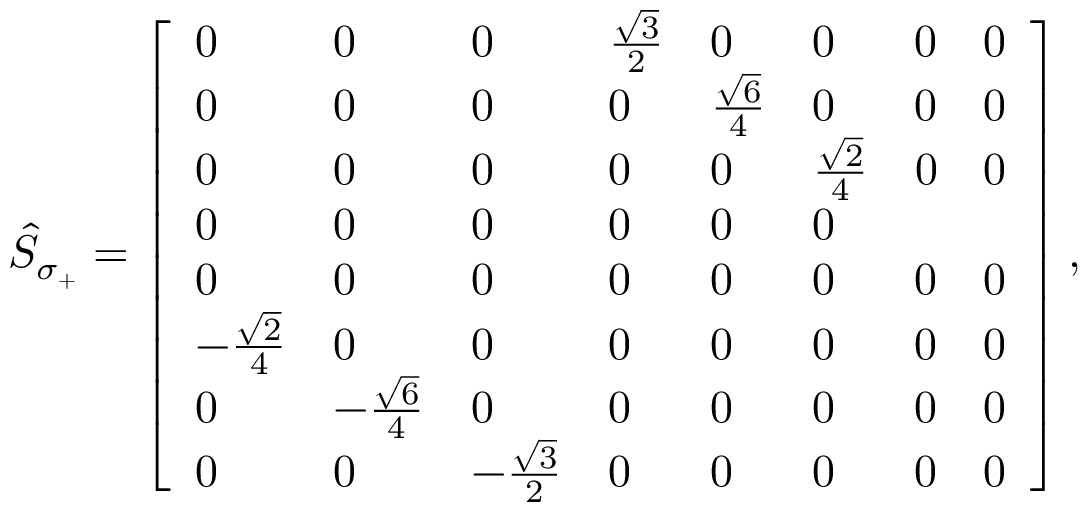<formula> <loc_0><loc_0><loc_500><loc_500>\begin{array} { r } { \hat { S } _ { \sigma _ { + } } = \left [ \begin{array} { l l l l l l l l } { 0 } & { 0 } & { 0 } & { \frac { \sqrt { 3 } } { 2 } } & { 0 } & { 0 } & { 0 } & { 0 } \\ { 0 } & { 0 } & { 0 } & { 0 } & { \frac { \sqrt { 6 } } { 4 } } & { 0 } & { 0 } & { 0 } \\ { 0 } & { 0 } & { 0 } & { 0 } & { 0 } & { \frac { \sqrt { 2 } } { 4 } } & { 0 } & { 0 } \\ { 0 } & { 0 } & { 0 } & { 0 } & { 0 } & { 0 } \\ { 0 } & { 0 } & { 0 } & { 0 } & { 0 } & { 0 } & { 0 } & { 0 } \\ { - \frac { \sqrt { 2 } } { 4 } } & { 0 } & { 0 } & { 0 } & { 0 } & { 0 } & { 0 } & { 0 } \\ { 0 } & { - \frac { \sqrt { 6 } } { 4 } } & { 0 } & { 0 } & { 0 } & { 0 } & { 0 } & { 0 } \\ { 0 } & { 0 } & { - \frac { \sqrt { 3 } } { 2 } } & { 0 } & { 0 } & { 0 } & { 0 } & { 0 } \end{array} \right ] , } \end{array}</formula> 